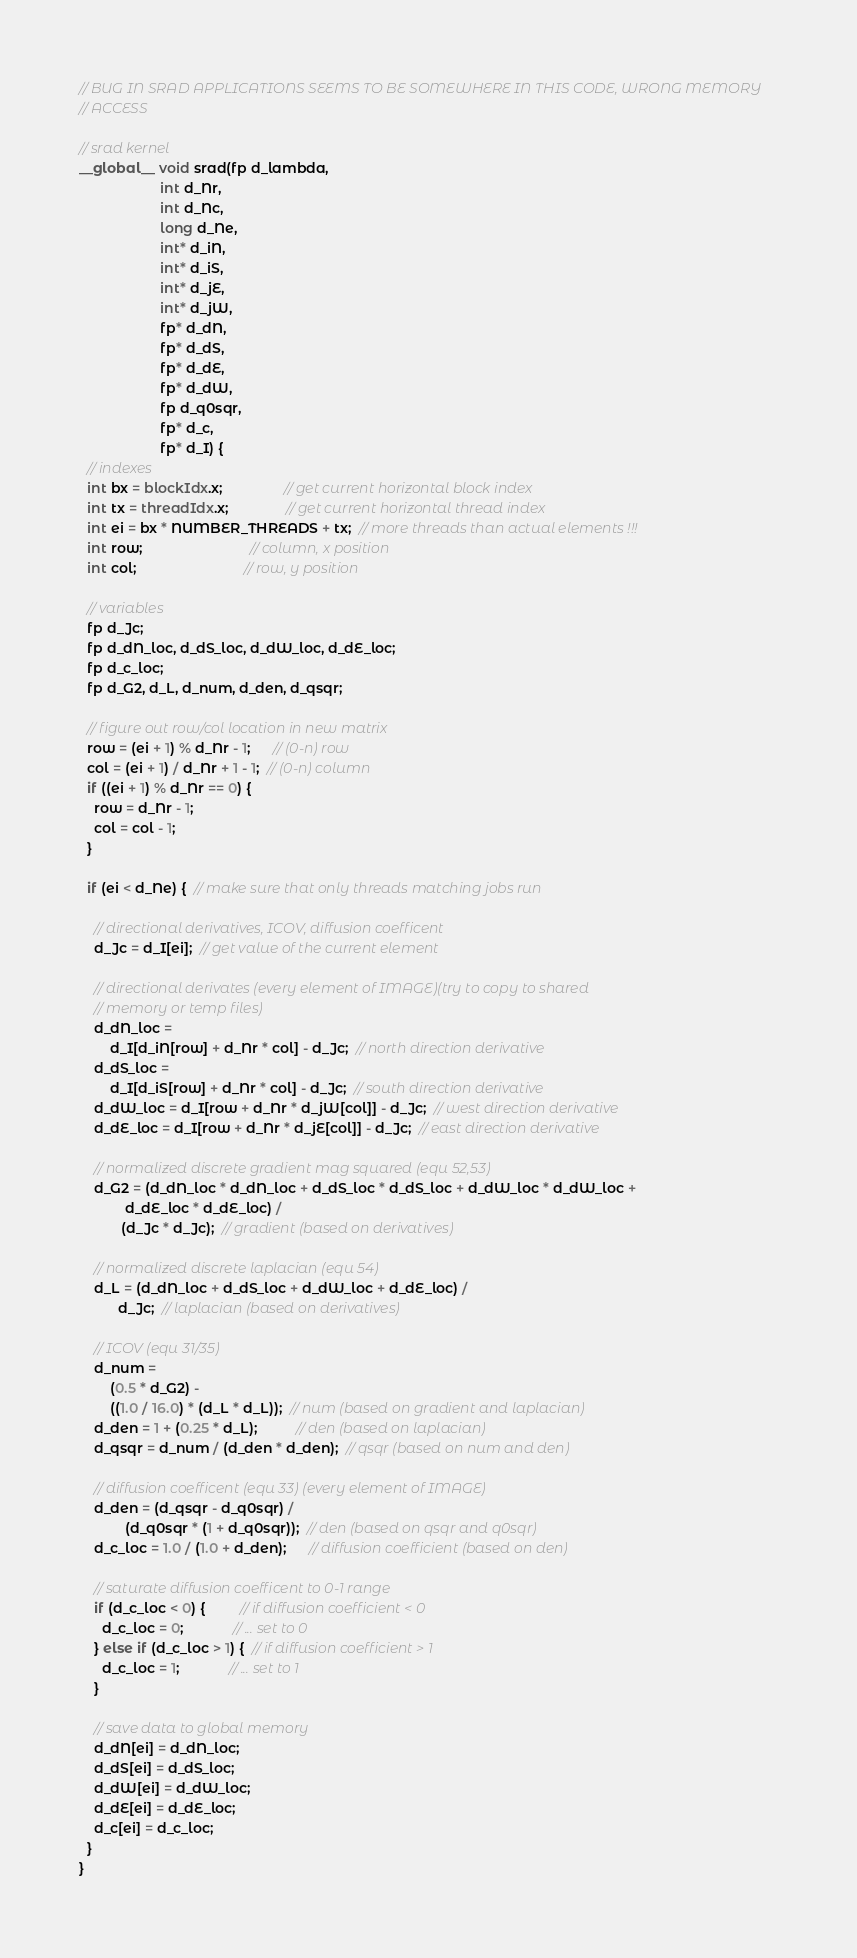<code> <loc_0><loc_0><loc_500><loc_500><_Cuda_>// BUG IN SRAD APPLICATIONS SEEMS TO BE SOMEWHERE IN THIS CODE, WRONG MEMORY
// ACCESS

// srad kernel
__global__ void srad(fp d_lambda,
                     int d_Nr,
                     int d_Nc,
                     long d_Ne,
                     int* d_iN,
                     int* d_iS,
                     int* d_jE,
                     int* d_jW,
                     fp* d_dN,
                     fp* d_dS,
                     fp* d_dE,
                     fp* d_dW,
                     fp d_q0sqr,
                     fp* d_c,
                     fp* d_I) {
  // indexes
  int bx = blockIdx.x;                // get current horizontal block index
  int tx = threadIdx.x;               // get current horizontal thread index
  int ei = bx * NUMBER_THREADS + tx;  // more threads than actual elements !!!
  int row;                            // column, x position
  int col;                            // row, y position

  // variables
  fp d_Jc;
  fp d_dN_loc, d_dS_loc, d_dW_loc, d_dE_loc;
  fp d_c_loc;
  fp d_G2, d_L, d_num, d_den, d_qsqr;

  // figure out row/col location in new matrix
  row = (ei + 1) % d_Nr - 1;      // (0-n) row
  col = (ei + 1) / d_Nr + 1 - 1;  // (0-n) column
  if ((ei + 1) % d_Nr == 0) {
    row = d_Nr - 1;
    col = col - 1;
  }

  if (ei < d_Ne) {  // make sure that only threads matching jobs run

    // directional derivatives, ICOV, diffusion coefficent
    d_Jc = d_I[ei];  // get value of the current element

    // directional derivates (every element of IMAGE)(try to copy to shared
    // memory or temp files)
    d_dN_loc =
        d_I[d_iN[row] + d_Nr * col] - d_Jc;  // north direction derivative
    d_dS_loc =
        d_I[d_iS[row] + d_Nr * col] - d_Jc;  // south direction derivative
    d_dW_loc = d_I[row + d_Nr * d_jW[col]] - d_Jc;  // west direction derivative
    d_dE_loc = d_I[row + d_Nr * d_jE[col]] - d_Jc;  // east direction derivative

    // normalized discrete gradient mag squared (equ 52,53)
    d_G2 = (d_dN_loc * d_dN_loc + d_dS_loc * d_dS_loc + d_dW_loc * d_dW_loc +
            d_dE_loc * d_dE_loc) /
           (d_Jc * d_Jc);  // gradient (based on derivatives)

    // normalized discrete laplacian (equ 54)
    d_L = (d_dN_loc + d_dS_loc + d_dW_loc + d_dE_loc) /
          d_Jc;  // laplacian (based on derivatives)

    // ICOV (equ 31/35)
    d_num =
        (0.5 * d_G2) -
        ((1.0 / 16.0) * (d_L * d_L));  // num (based on gradient and laplacian)
    d_den = 1 + (0.25 * d_L);          // den (based on laplacian)
    d_qsqr = d_num / (d_den * d_den);  // qsqr (based on num and den)

    // diffusion coefficent (equ 33) (every element of IMAGE)
    d_den = (d_qsqr - d_q0sqr) /
            (d_q0sqr * (1 + d_q0sqr));  // den (based on qsqr and q0sqr)
    d_c_loc = 1.0 / (1.0 + d_den);      // diffusion coefficient (based on den)

    // saturate diffusion coefficent to 0-1 range
    if (d_c_loc < 0) {         // if diffusion coefficient < 0
      d_c_loc = 0;             // ... set to 0
    } else if (d_c_loc > 1) {  // if diffusion coefficient > 1
      d_c_loc = 1;             // ... set to 1
    }

    // save data to global memory
    d_dN[ei] = d_dN_loc;
    d_dS[ei] = d_dS_loc;
    d_dW[ei] = d_dW_loc;
    d_dE[ei] = d_dE_loc;
    d_c[ei] = d_c_loc;
  }
}
</code> 